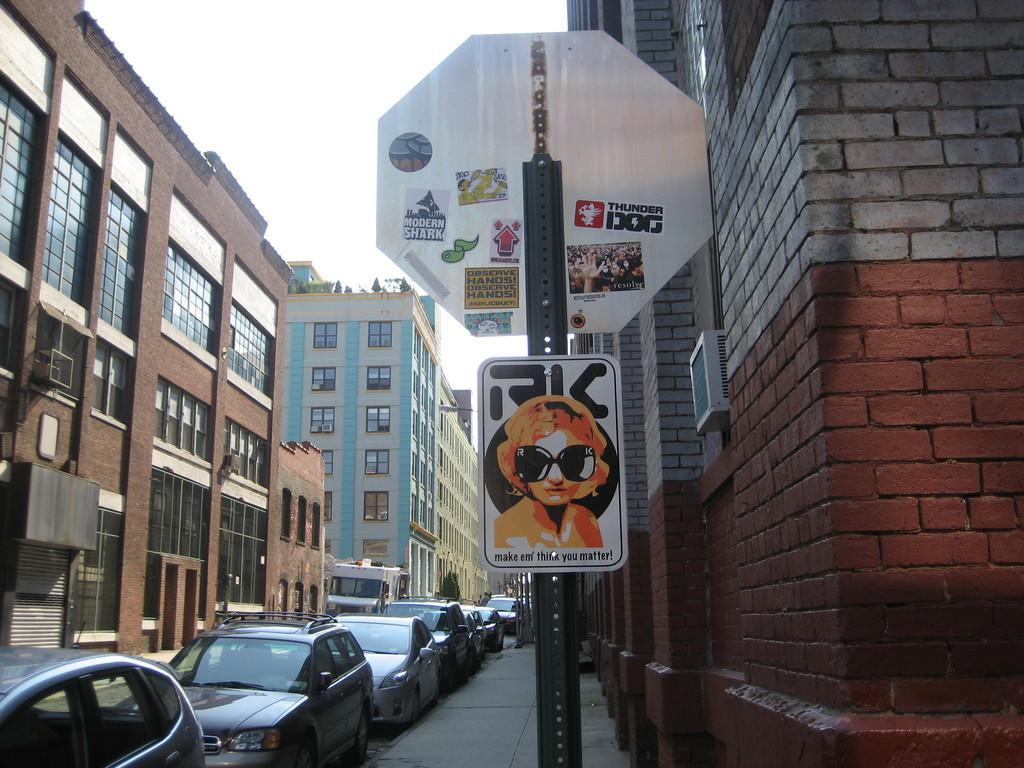Can you describe this image briefly? The image is clicked on the street of a city. In the foreground there is a pole, on the pole there are two boards. On the right we can see brick walls and air conditioner. In the center of the picture there are cars, footpath, truck, road and trees. On the left there are buildings. At the top it is sky. 